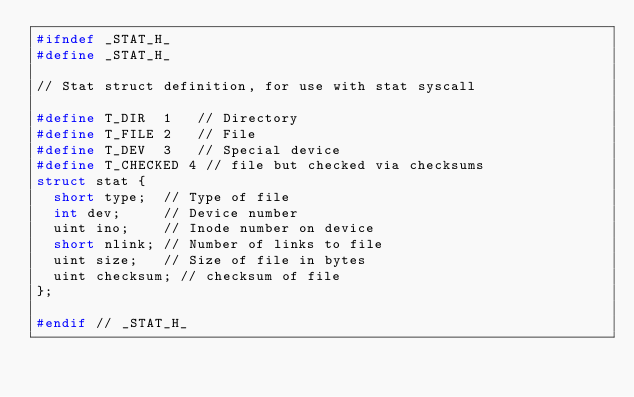Convert code to text. <code><loc_0><loc_0><loc_500><loc_500><_C_>#ifndef _STAT_H_
#define _STAT_H_

// Stat struct definition, for use with stat syscall

#define T_DIR  1   // Directory
#define T_FILE 2   // File
#define T_DEV  3   // Special device
#define T_CHECKED 4 // file but checked via checksums
struct stat {
  short type;  // Type of file
  int dev;     // Device number
  uint ino;    // Inode number on device
  short nlink; // Number of links to file
  uint size;   // Size of file in bytes
  uint checksum; // checksum of file
};

#endif // _STAT_H_
</code> 